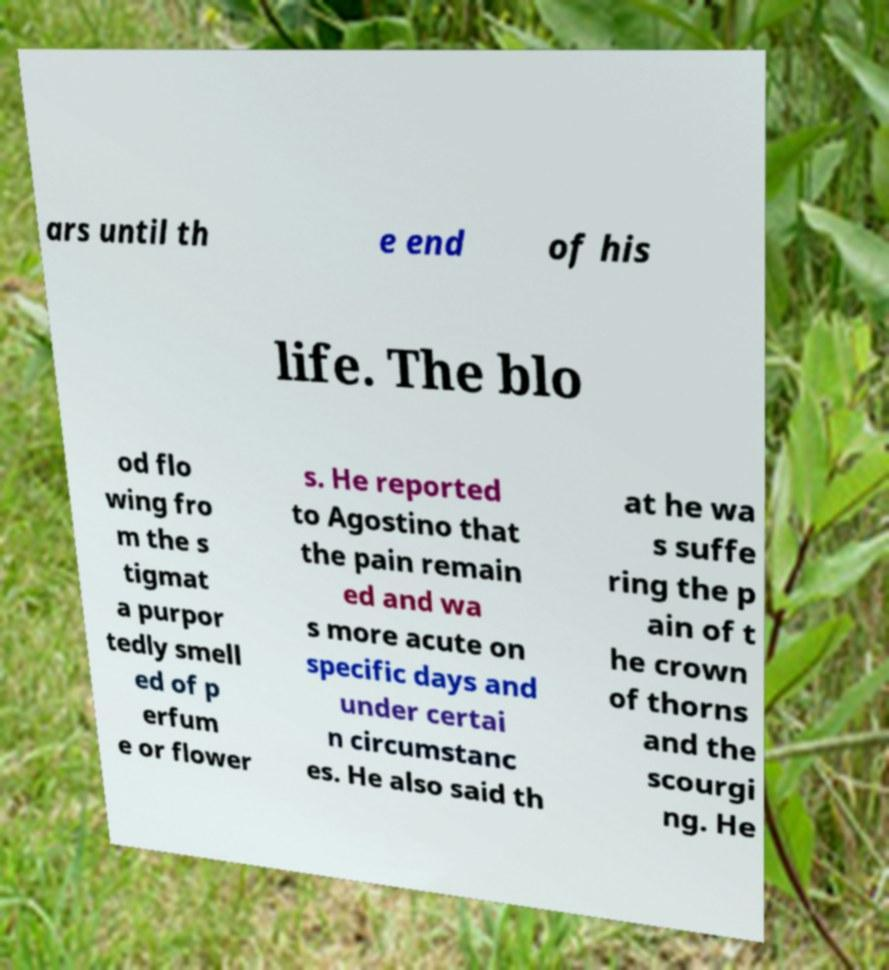What messages or text are displayed in this image? I need them in a readable, typed format. ars until th e end of his life. The blo od flo wing fro m the s tigmat a purpor tedly smell ed of p erfum e or flower s. He reported to Agostino that the pain remain ed and wa s more acute on specific days and under certai n circumstanc es. He also said th at he wa s suffe ring the p ain of t he crown of thorns and the scourgi ng. He 